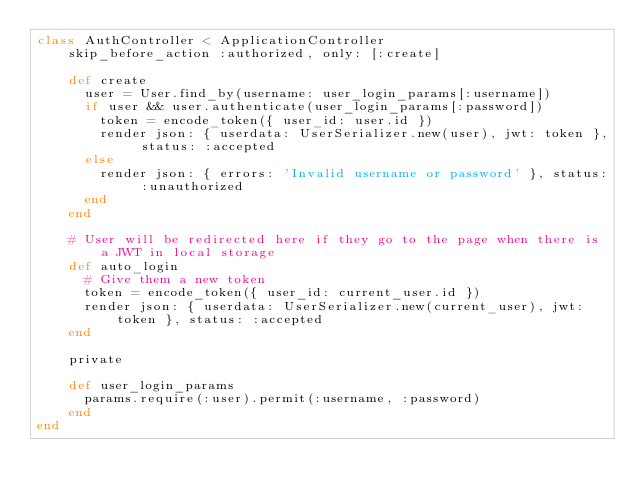<code> <loc_0><loc_0><loc_500><loc_500><_Ruby_>class AuthController < ApplicationController
    skip_before_action :authorized, only: [:create]

    def create
      user = User.find_by(username: user_login_params[:username])
      if user && user.authenticate(user_login_params[:password])
        token = encode_token({ user_id: user.id })
        render json: { userdata: UserSerializer.new(user), jwt: token }, status: :accepted
      else
        render json: { errors: 'Invalid username or password' }, status: :unauthorized
      end
    end

    # User will be redirected here if they go to the page when there is a JWT in local storage
    def auto_login
      # Give them a new token
      token = encode_token({ user_id: current_user.id })
      render json: { userdata: UserSerializer.new(current_user), jwt: token }, status: :accepted
    end
  
    private
  
    def user_login_params
      params.require(:user).permit(:username, :password)
    end
end</code> 